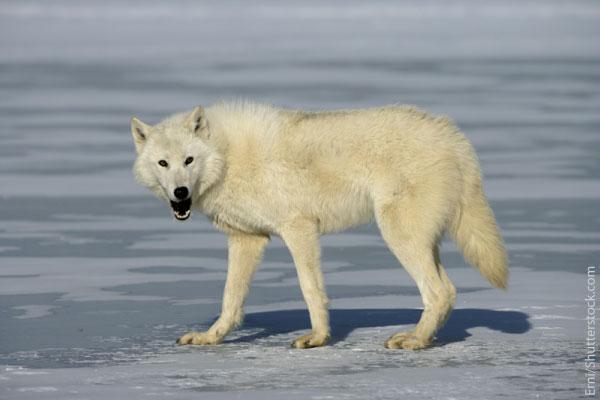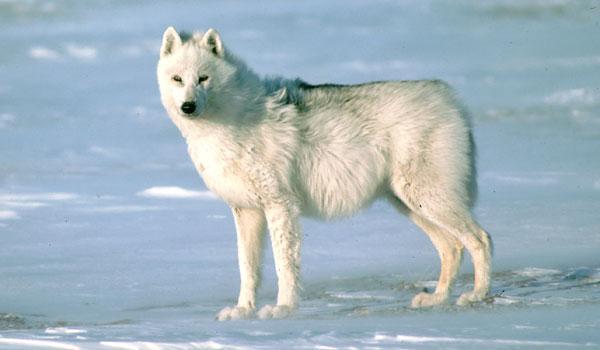The first image is the image on the left, the second image is the image on the right. Assess this claim about the two images: "There is a single white wolf in each of the images.". Correct or not? Answer yes or no. Yes. The first image is the image on the left, the second image is the image on the right. Analyze the images presented: Is the assertion "A dog has its mouth open." valid? Answer yes or no. Yes. 